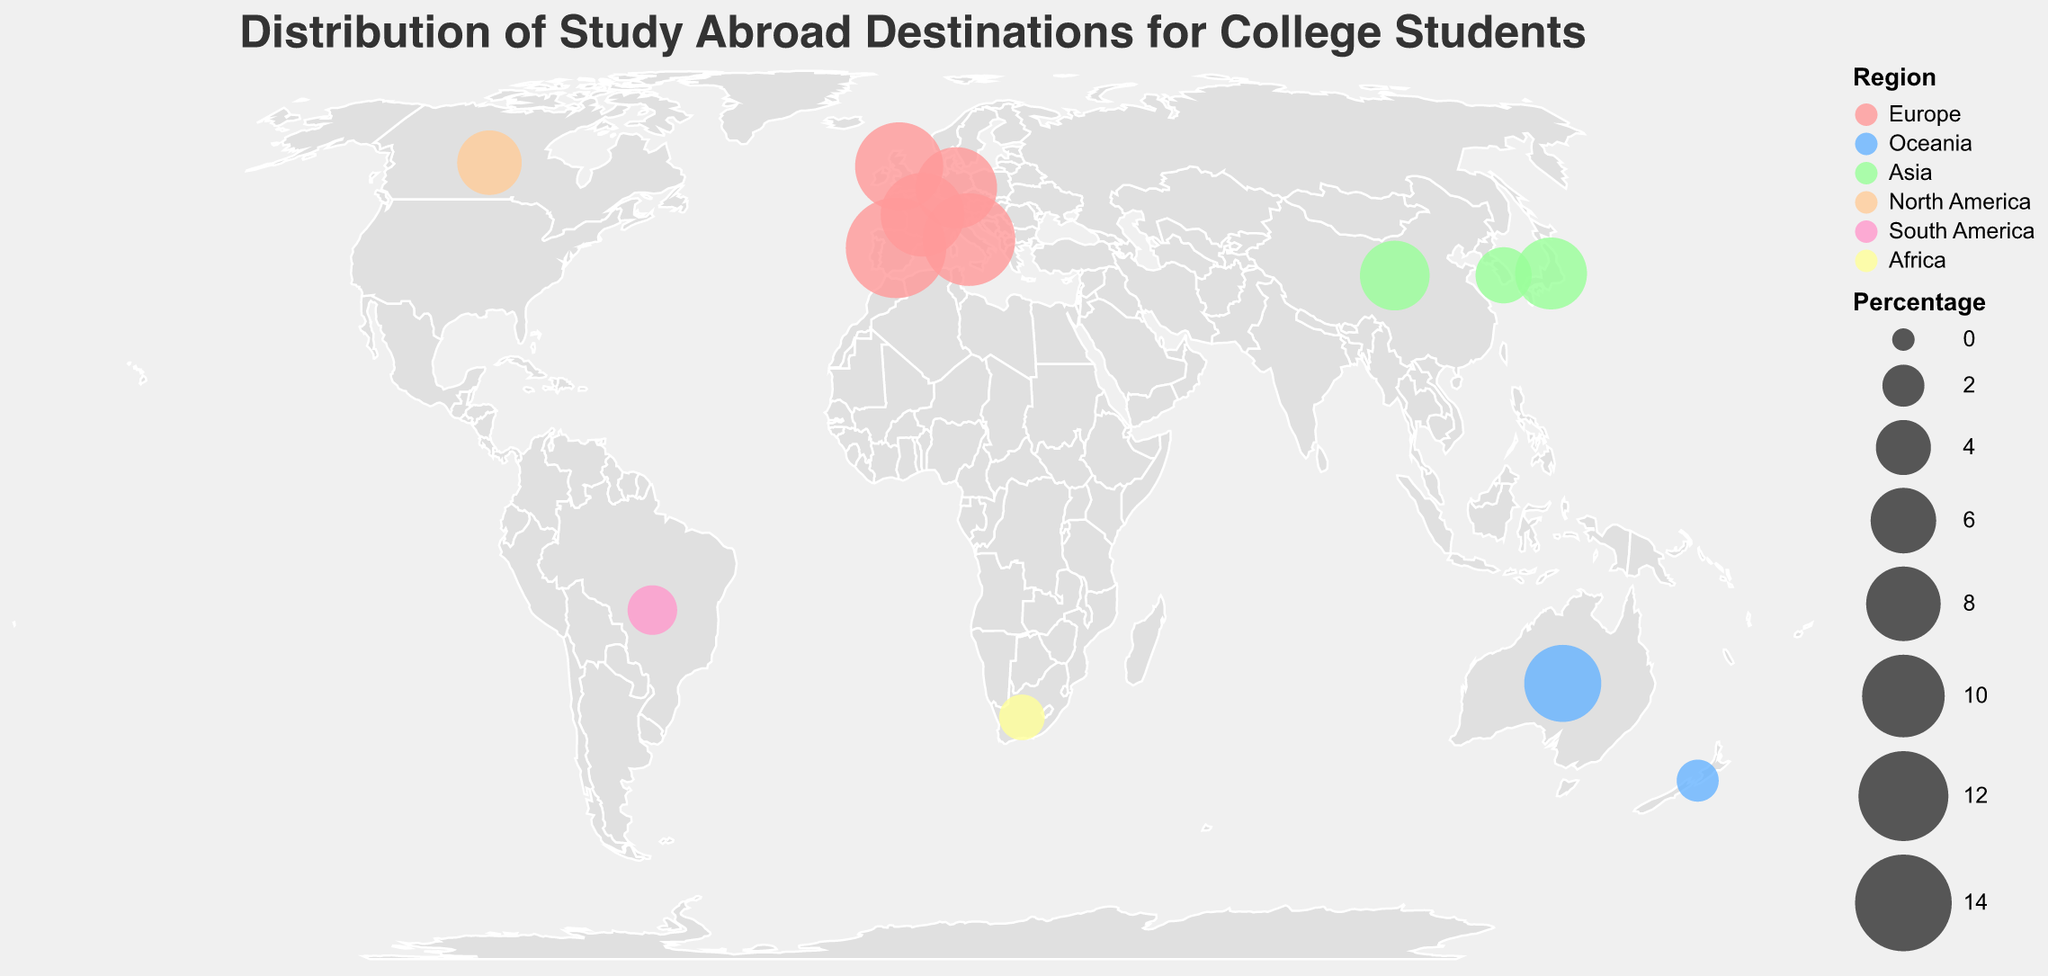What is the title of the plot? The title of the plot is displayed at the top and it indicates the subject of the visual representation. The title is a straightforward element to identify.
Answer: Distribution of Study Abroad Destinations for College Students How many European countries are listed in the plot? To determine this, identify the countries marked with the color representing Europe and count them. Spain, Italy, United Kingdom, France, and Germany are five countries that belong to Europe.
Answer: 5 Which country has the highest percentage of students studying abroad? Check the size of the circles representing each country. The largest circle corresponds to Spain with a percentage value of 15.2.
Answer: Spain Which region has the most countries listed in the plot? Count the number of countries listed for each region by looking at the color-coded circles. Europe has five countries: Spain, Italy, United Kingdom, France, and Germany.
Answer: Europe What is the total percentage of students studying abroad in Asia? Add the percentages of all countries in Asia: Japan (7.4), China (6.9), and South Korea (4.2). Summing these gives 7.4 + 6.9 + 4.2 = 18.5.
Answer: 18.5 How does the percentage of students studying in Australia compare to that in New Zealand? Look at the size of circles for Australia and New Zealand. Australia's percentage (8.6) is significantly larger than New Zealand's (2.0).
Answer: Australia has a higher percentage Which African country is included in the plot and what is its percentage? Identify the country in Africa by looking for the representative color. South Africa is the only African country listed, with a percentage of 2.5.
Answer: South Africa, 2.5 What is the average percentage of students studying abroad in Oceania? Add the percentages of the two countries in Oceania: Australia (8.6) and New Zealand (2.0). Sum them up: 8.6 + 2.0 = 10.6. Divide by 2 to get the average: 10.6 / 2 = 5.3.
Answer: 5.3 Which country in North America is listed and what color represents it? Identify the country in North America by looking at the color assigned to the region and the specific country label. Canada is the country listed, and it is represented by the color assigned to North America, which is a shade of orange.
Answer: Canada, orange What are the countries and their percentages in South America and Africa combined? List the countries and percentages in South America (Brazil, 3.1) and Africa (South Africa, 2.5). Combine them into a straightforward response: Brazil (3.1) and South Africa (2.5).
Answer: Brazil (3.1), South Africa (2.5) 